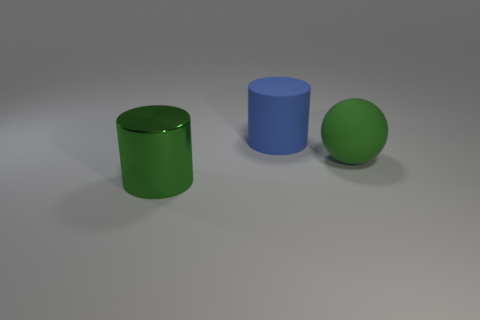Add 1 spheres. How many objects exist? 4 Subtract all spheres. How many objects are left? 2 Subtract all large gray things. Subtract all green things. How many objects are left? 1 Add 2 blue objects. How many blue objects are left? 3 Add 1 small cyan things. How many small cyan things exist? 1 Subtract 0 cyan cylinders. How many objects are left? 3 